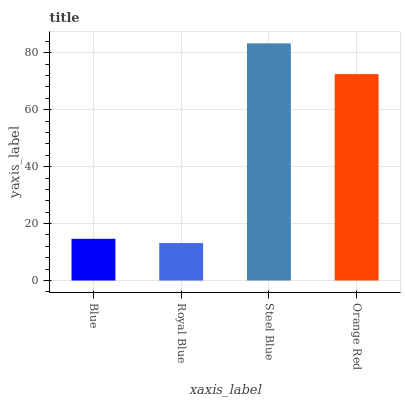Is Steel Blue the minimum?
Answer yes or no. No. Is Royal Blue the maximum?
Answer yes or no. No. Is Steel Blue greater than Royal Blue?
Answer yes or no. Yes. Is Royal Blue less than Steel Blue?
Answer yes or no. Yes. Is Royal Blue greater than Steel Blue?
Answer yes or no. No. Is Steel Blue less than Royal Blue?
Answer yes or no. No. Is Orange Red the high median?
Answer yes or no. Yes. Is Blue the low median?
Answer yes or no. Yes. Is Blue the high median?
Answer yes or no. No. Is Orange Red the low median?
Answer yes or no. No. 